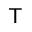<formula> <loc_0><loc_0><loc_500><loc_500>T</formula> 